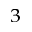Convert formula to latex. <formula><loc_0><loc_0><loc_500><loc_500>^ { 3 }</formula> 